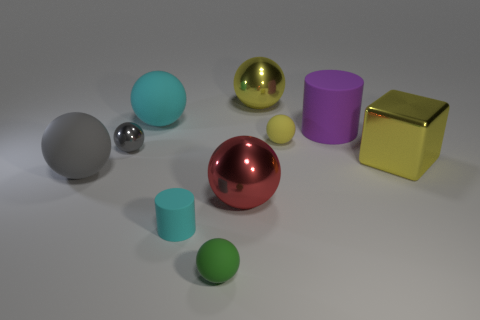There is a yellow object that is the same size as the metal block; what shape is it?
Make the answer very short. Sphere. There is a tiny sphere that is to the right of the big yellow metallic ball on the right side of the small green ball; what number of large purple cylinders are behind it?
Make the answer very short. 1. What number of matte objects are yellow spheres or small objects?
Your response must be concise. 3. There is a large metallic object that is both in front of the big purple cylinder and to the left of the purple rubber cylinder; what color is it?
Your answer should be very brief. Red. Do the cyan rubber object that is in front of the red metal thing and the big red object have the same size?
Provide a succinct answer. No. What number of things are either small rubber balls behind the red metallic object or yellow metal cubes?
Offer a very short reply. 2. Are there any cylinders that have the same size as the yellow cube?
Give a very brief answer. Yes. What is the material of the cyan object that is the same size as the purple cylinder?
Offer a terse response. Rubber. The metallic object that is both right of the large red metal sphere and left of the big shiny block has what shape?
Make the answer very short. Sphere. The rubber cylinder behind the gray matte ball is what color?
Provide a succinct answer. Purple. 